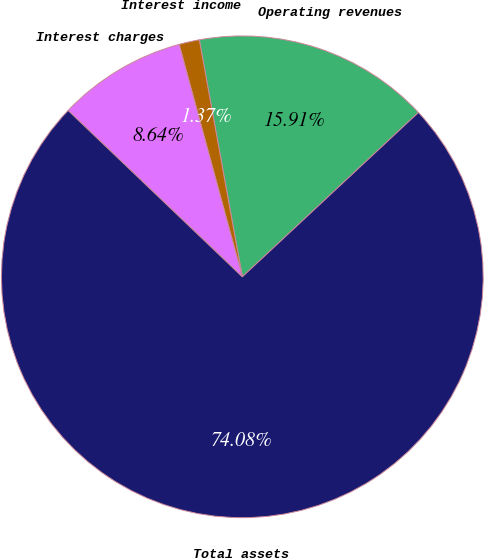<chart> <loc_0><loc_0><loc_500><loc_500><pie_chart><fcel>Operating revenues<fcel>Interest income<fcel>Interest charges<fcel>Total assets<nl><fcel>15.91%<fcel>1.37%<fcel>8.64%<fcel>74.09%<nl></chart> 